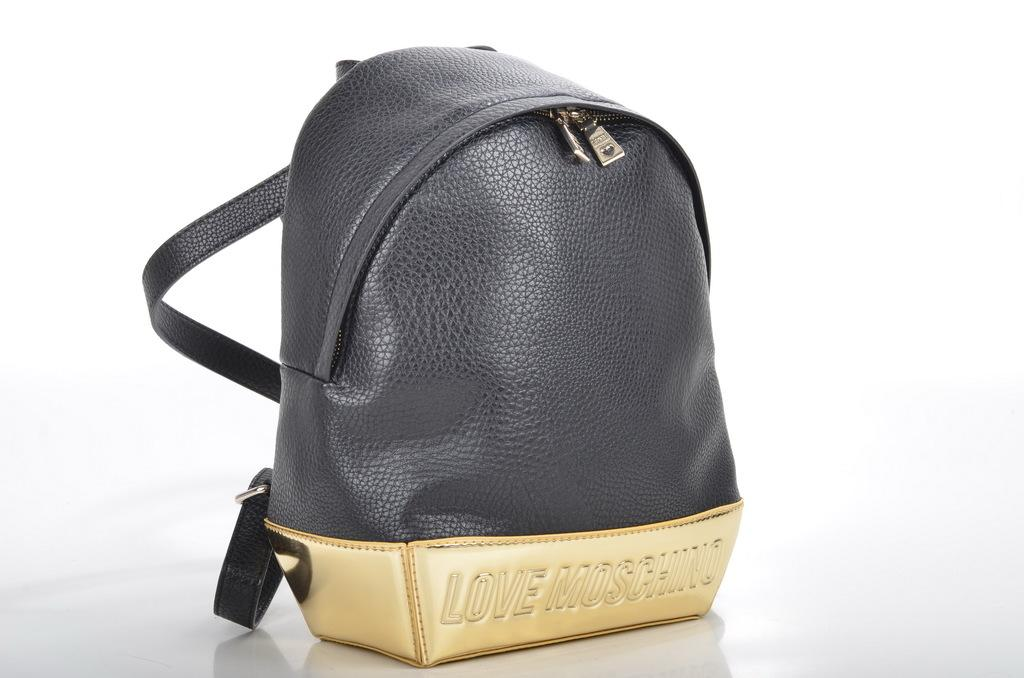What object is present in the image? There is a bag in the image. What colors are used for the bag? The bag is black and gold in color. How is the bag emphasized in the image? The bag is highlighted in the image. What date is circled on the calendar in the image? There is no calendar present in the image, so it is not possible to answer that question. 